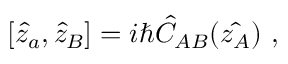<formula> <loc_0><loc_0><loc_500><loc_500>[ \hat { z } _ { a } , \hat { z } _ { B } ] = i \hbar { \hat } { C } _ { A B } ( \hat { z _ { A } } ) \ ,</formula> 